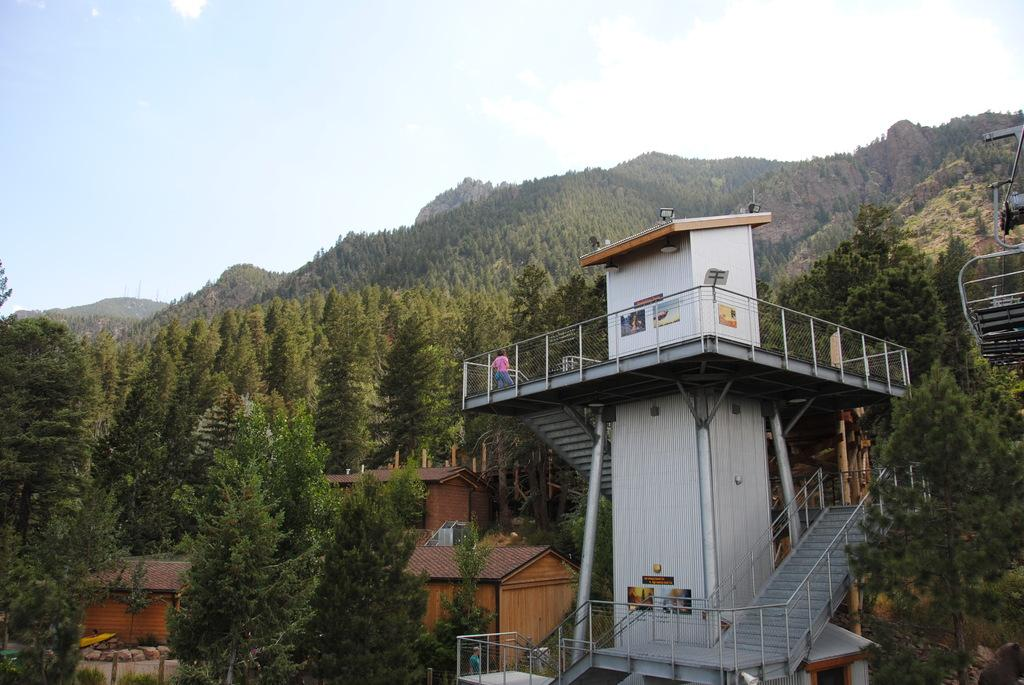What type of structures can be seen in the image? There are buildings in the image. What other natural elements are present in the image? There are trees in the image. What is the person in the image doing? The person is standing on a tower in the image. Can you describe any other objects in the image? There are other objects in the image, but their specific details are not mentioned in the facts. What can be seen in the background of the image? The sky and hills are visible in the background of the image. Can you see a snail smashing into the tower in the image? No, there is no snail or any smashing action depicted in the image. What type of bird is perched on the person's shoulder in the image? There is no bird present in the image; the person is standing on a tower without any bird. 